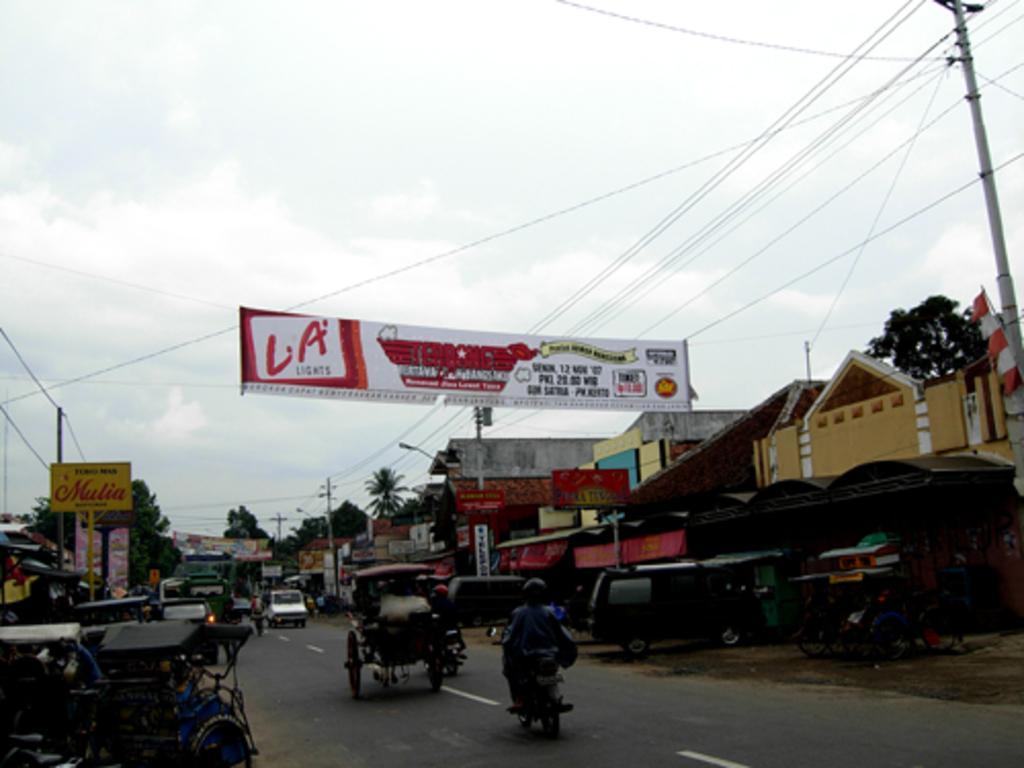How would you summarize this image in a sentence or two? In this image, I can see two people riding motorcycles and vehicles moving on the road. This is a banner hanging. On the left side of the image, I can see few vehicles parked and a board attached to a pole. In the background, I can see the trees and buildings. On the right side of the image, there are few other vehicles parked and a current pole with the current wires. At the top of the image, I can see the sky. 